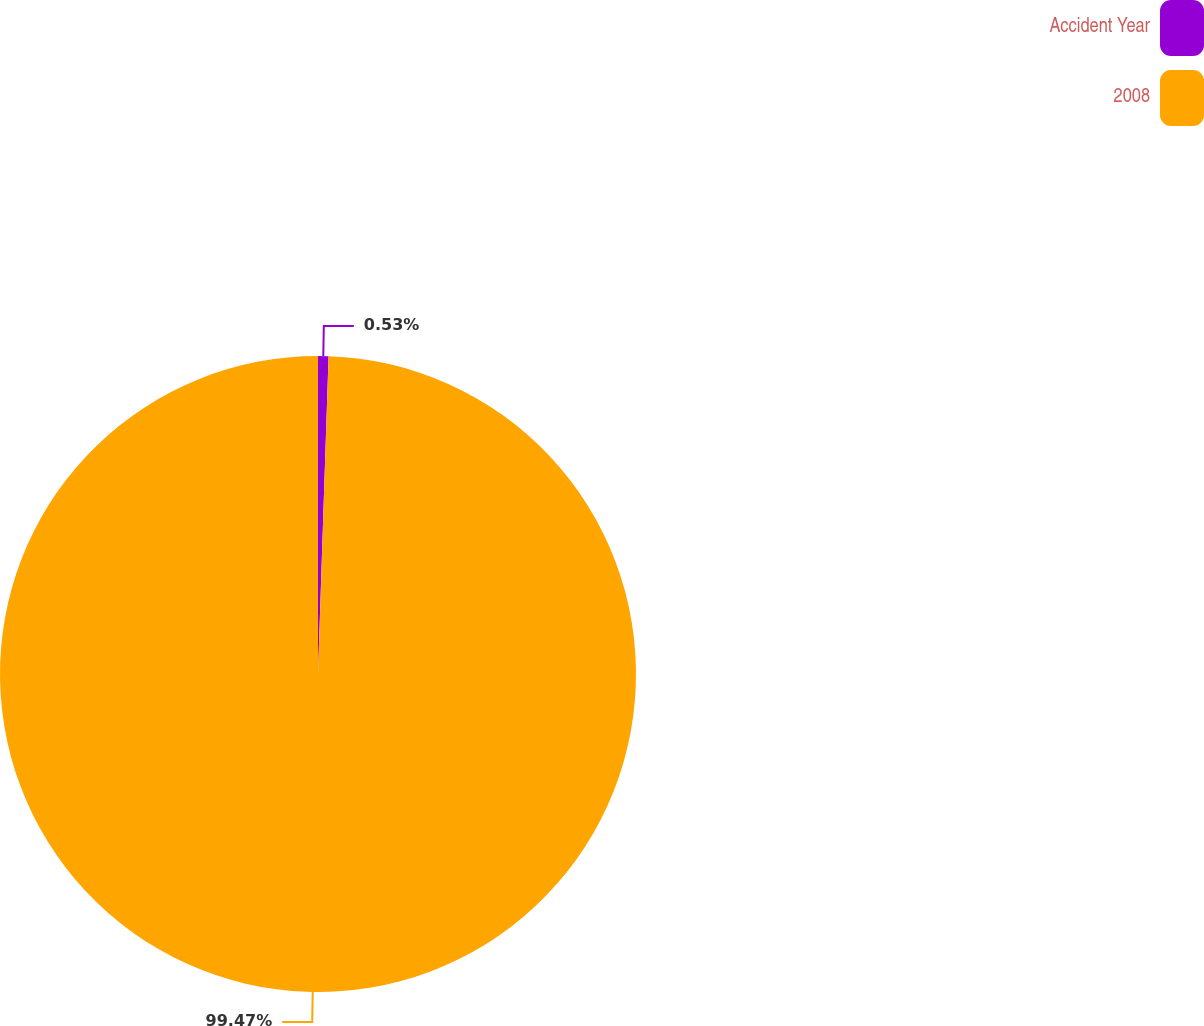Convert chart. <chart><loc_0><loc_0><loc_500><loc_500><pie_chart><fcel>Accident Year<fcel>2008<nl><fcel>0.53%<fcel>99.47%<nl></chart> 